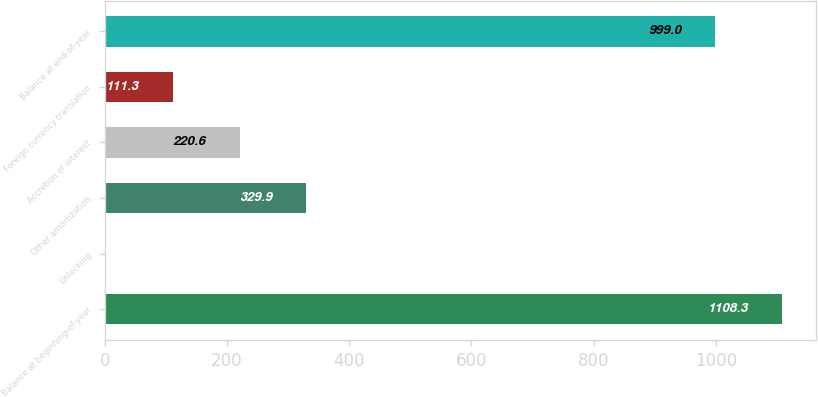Convert chart to OTSL. <chart><loc_0><loc_0><loc_500><loc_500><bar_chart><fcel>Balance at beginning-of-year<fcel>Unlocking<fcel>Other amortization<fcel>Accretion of interest<fcel>Foreign currency translation<fcel>Balance at end-of-year<nl><fcel>1108.3<fcel>2<fcel>329.9<fcel>220.6<fcel>111.3<fcel>999<nl></chart> 